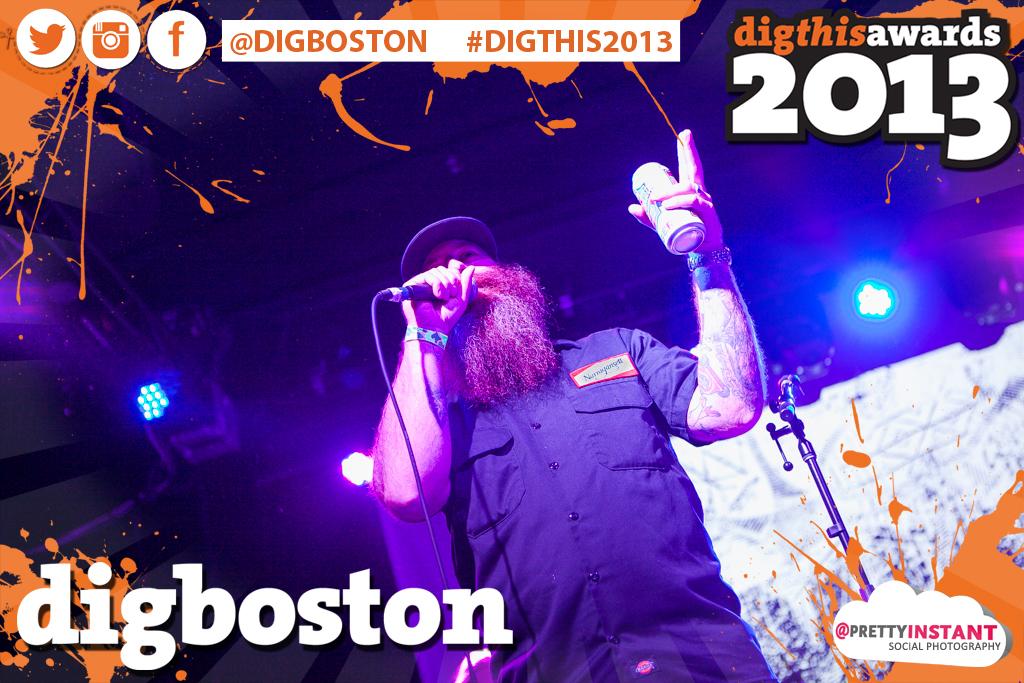What year are these awards in?
Offer a very short reply. 2013. What is the hashtag?
Keep it short and to the point. Digthis2013. 